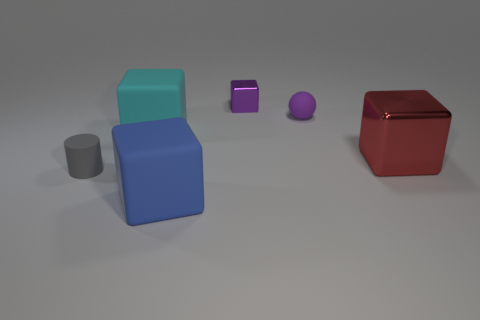Are there any other objects of the same shape as the tiny purple rubber thing?
Your answer should be compact. No. What size is the purple object left of the sphere?
Your answer should be very brief. Small. There is a cylinder that is the same size as the purple rubber thing; what material is it?
Provide a short and direct response. Rubber. Is the number of big green matte cubes greater than the number of cyan blocks?
Your answer should be compact. No. There is a matte block that is behind the metallic block that is right of the tiny metal block; what size is it?
Keep it short and to the point. Large. There is a matte object that is the same size as the blue matte cube; what is its shape?
Provide a succinct answer. Cube. The metal object that is behind the large object on the left side of the big thing in front of the small gray rubber cylinder is what shape?
Give a very brief answer. Cube. Does the large thing that is in front of the large red block have the same color as the object left of the large cyan cube?
Offer a very short reply. No. How many tiny cyan rubber objects are there?
Keep it short and to the point. 0. There is a blue rubber object; are there any big rubber objects in front of it?
Ensure brevity in your answer.  No. 